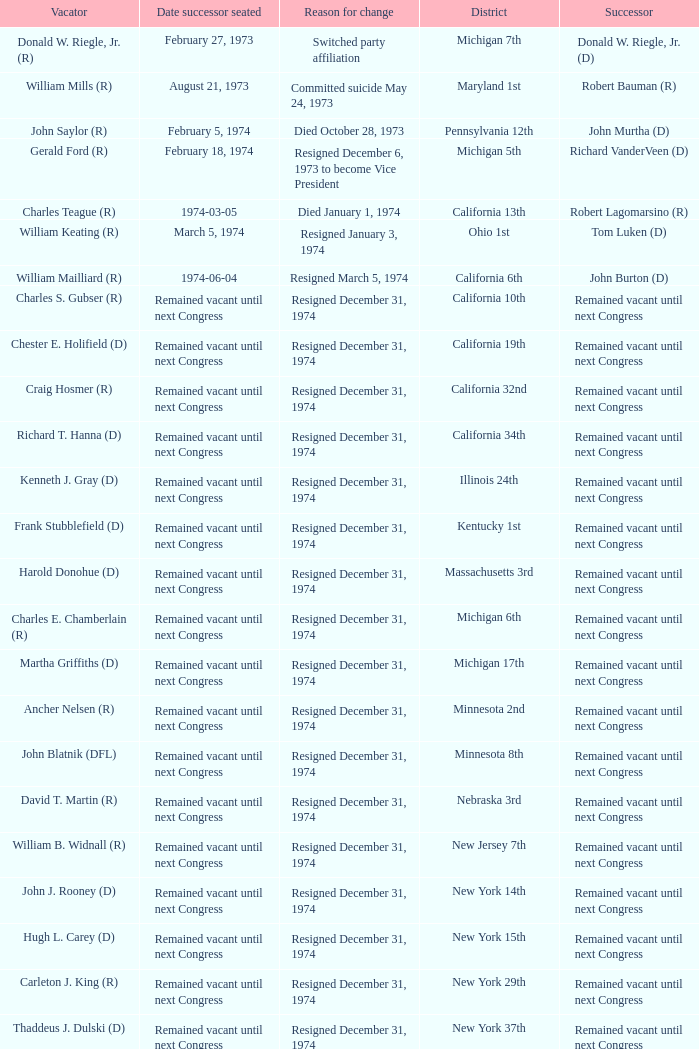Who was the successor when the vacator was chester e. holifield (d)? Remained vacant until next Congress. 